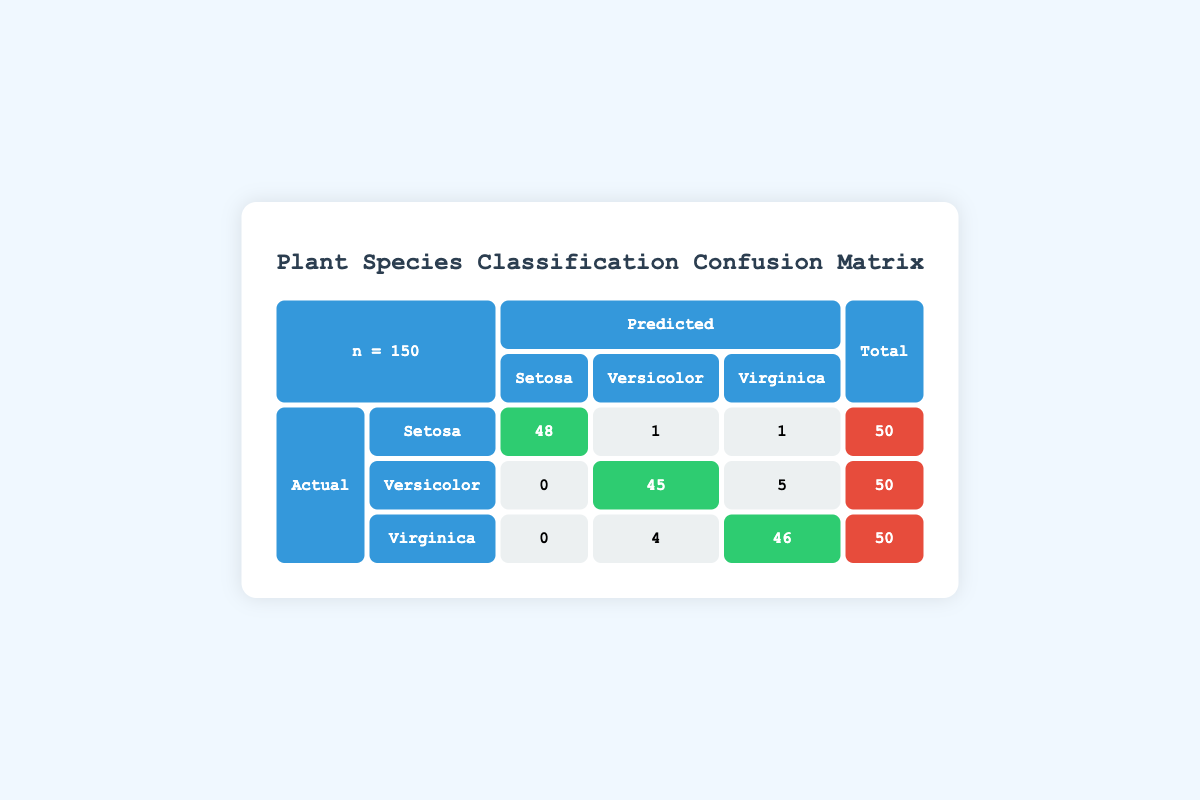What is the total number of predicted Setosa plants? In the predicted column, the values for Setosa are 48 (correctly predicted) + 0 (false positives from Versicolor) + 0 (false positives from Virginica), totaling 48.
Answer: 48 What is the total number of actual Virginica plants classified as Versicolor? Looking at the Virginica row under Versicolor, there are 4 plants predicted as Versicolor.
Answer: 4 How many plants of each species were correctly predicted? The correctly predicted plants are: Setosa - 48, Versicolor - 45, and Virginica - 46.
Answer: Setosa: 48, Versicolor: 45, Virginica: 46 What is the overall classification accuracy of the model? The correct predictions (48 + 45 + 46 = 139) divided by the total number of plants (150) gives us an accuracy of 139/150 = 0.93 or 93%.
Answer: 93% Is there any misclassification of the Virginica species? Yes, there are 4 Virginica plants misclassified as Versicolor, indicating some level of misclassification.
Answer: Yes What percentage of the predicted Versicolor plants were actually Versicolor? The number of correctly predicted Versicolor plants is 45 out of a total of 50 predicted as Versicolor. Thus, the percentage is (45/50) * 100 = 90%.
Answer: 90% What is the total number of misclassified plants? We add the misclassifications across all species: 1 Setosa + 5 Virginica predicted as Versicolor + 1 Virginica predicted as Setosa + 4 predicted as Versicolor = 11 misclassified plants.
Answer: 11 How many Setosa plants were incorrectly classified as Virginica? Looking at the Setosa row, we see that 1 Setosa was incorrectly classified as Virginica.
Answer: 1 What is the total number of plants predicted as Virginica? In the predicted Virginica row, we sum the values: 1 (from Setosa) + 5 (from Versicolor) + 46 (which are correctly predicted Virginica) for a total of 52 predicted as Virginica.
Answer: 52 